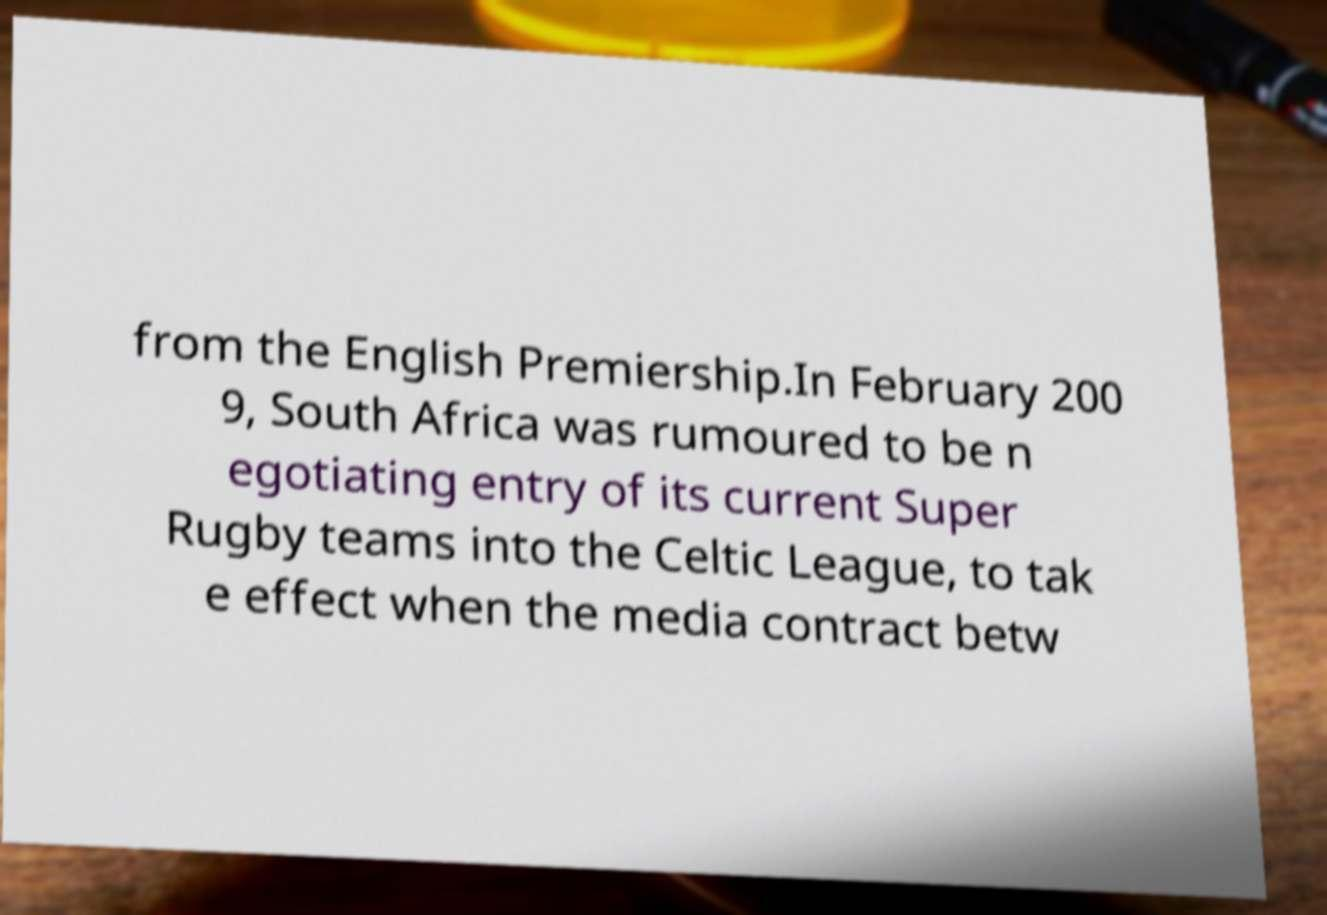Could you assist in decoding the text presented in this image and type it out clearly? from the English Premiership.In February 200 9, South Africa was rumoured to be n egotiating entry of its current Super Rugby teams into the Celtic League, to tak e effect when the media contract betw 